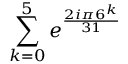Convert formula to latex. <formula><loc_0><loc_0><loc_500><loc_500>\sum _ { k = 0 } ^ { 5 } e ^ { \frac { 2 i \pi 6 ^ { k } } { 3 1 } }</formula> 